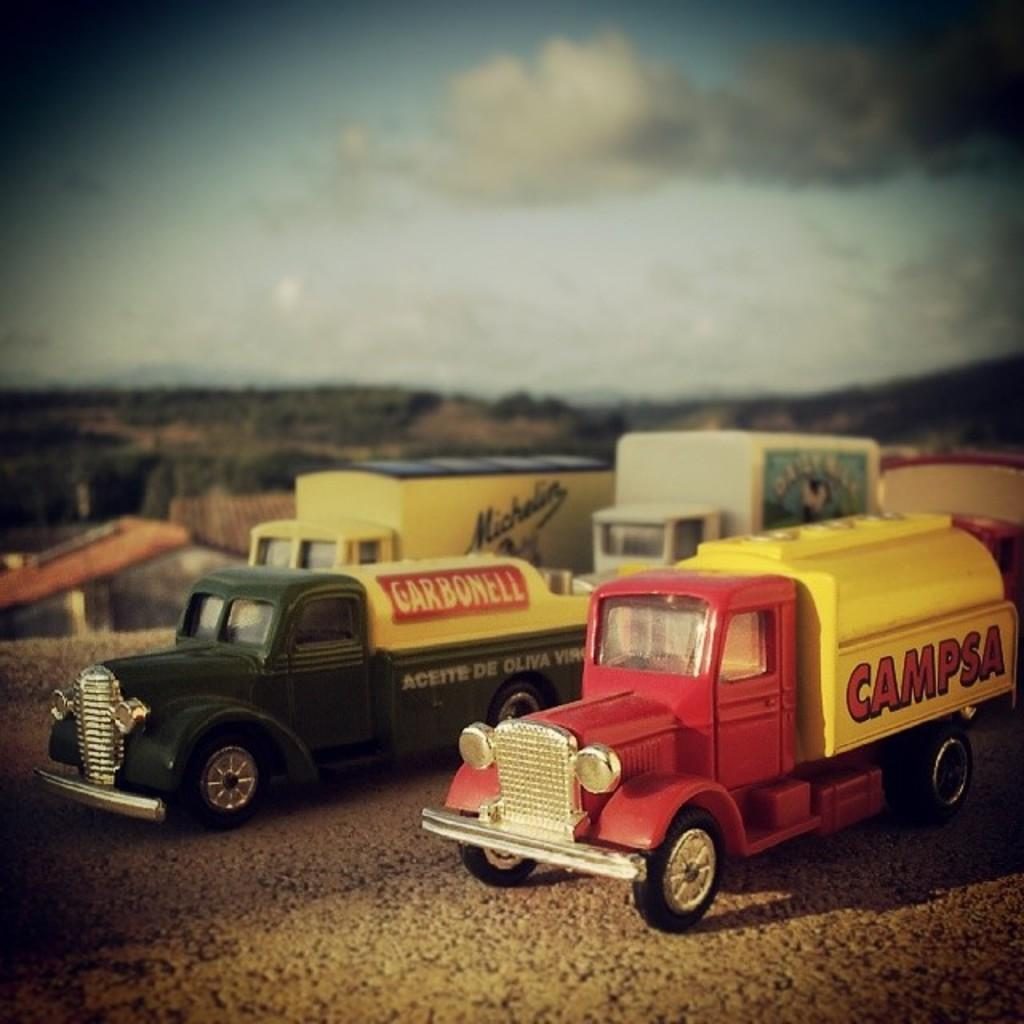What can be seen in large numbers in the image? There are many vehicles in the image. What is present on the vehicles? There is writing on the vehicles. How would you describe the background of the image? The background of the image is blurred. What type of pipe is visible in the image? There is no pipe present in the image. How does the shape of the vehicles affect their control in the image? The shape of the vehicles does not affect their control in the image, as the vehicles are stationary and not in motion. 